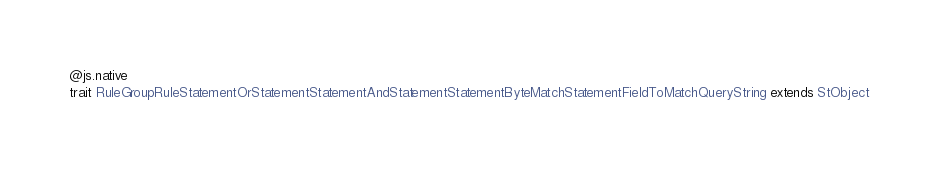<code> <loc_0><loc_0><loc_500><loc_500><_Scala_>@js.native
trait RuleGroupRuleStatementOrStatementStatementAndStatementStatementByteMatchStatementFieldToMatchQueryString extends StObject
</code> 